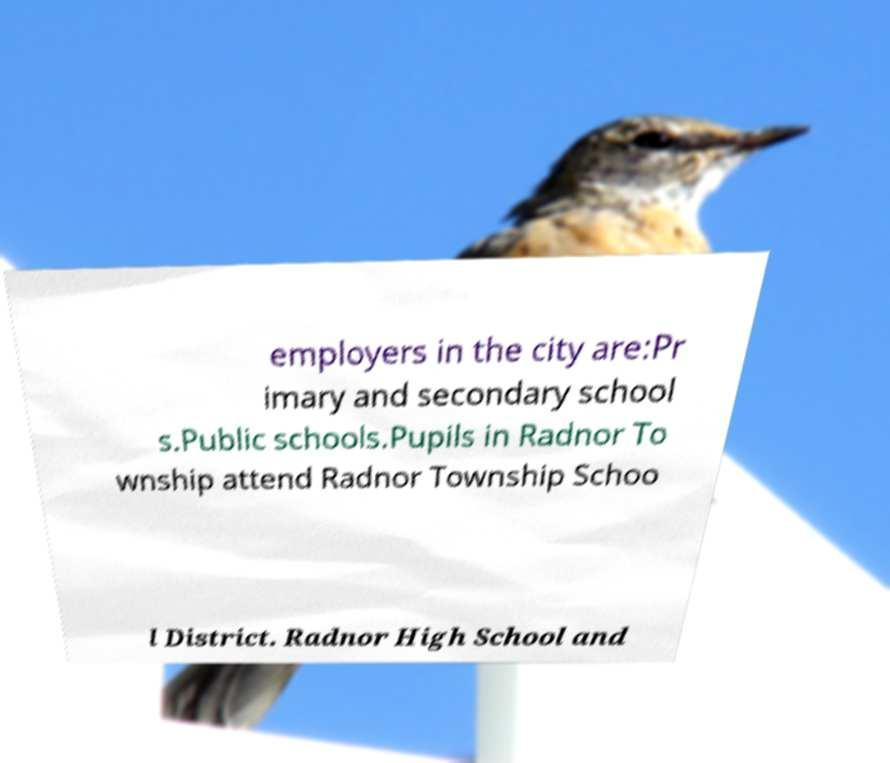For documentation purposes, I need the text within this image transcribed. Could you provide that? employers in the city are:Pr imary and secondary school s.Public schools.Pupils in Radnor To wnship attend Radnor Township Schoo l District. Radnor High School and 